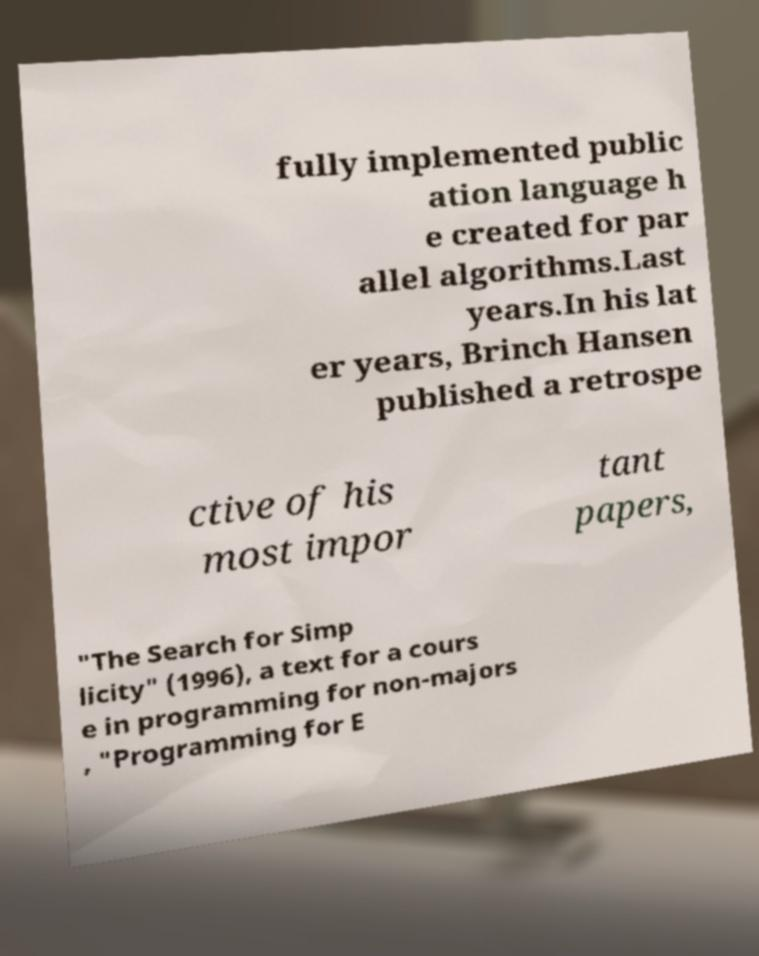Can you read and provide the text displayed in the image?This photo seems to have some interesting text. Can you extract and type it out for me? fully implemented public ation language h e created for par allel algorithms.Last years.In his lat er years, Brinch Hansen published a retrospe ctive of his most impor tant papers, "The Search for Simp licity" (1996), a text for a cours e in programming for non-majors , "Programming for E 